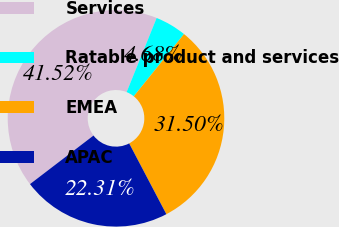Convert chart. <chart><loc_0><loc_0><loc_500><loc_500><pie_chart><fcel>Services<fcel>Ratable product and services<fcel>EMEA<fcel>APAC<nl><fcel>41.52%<fcel>4.68%<fcel>31.5%<fcel>22.31%<nl></chart> 